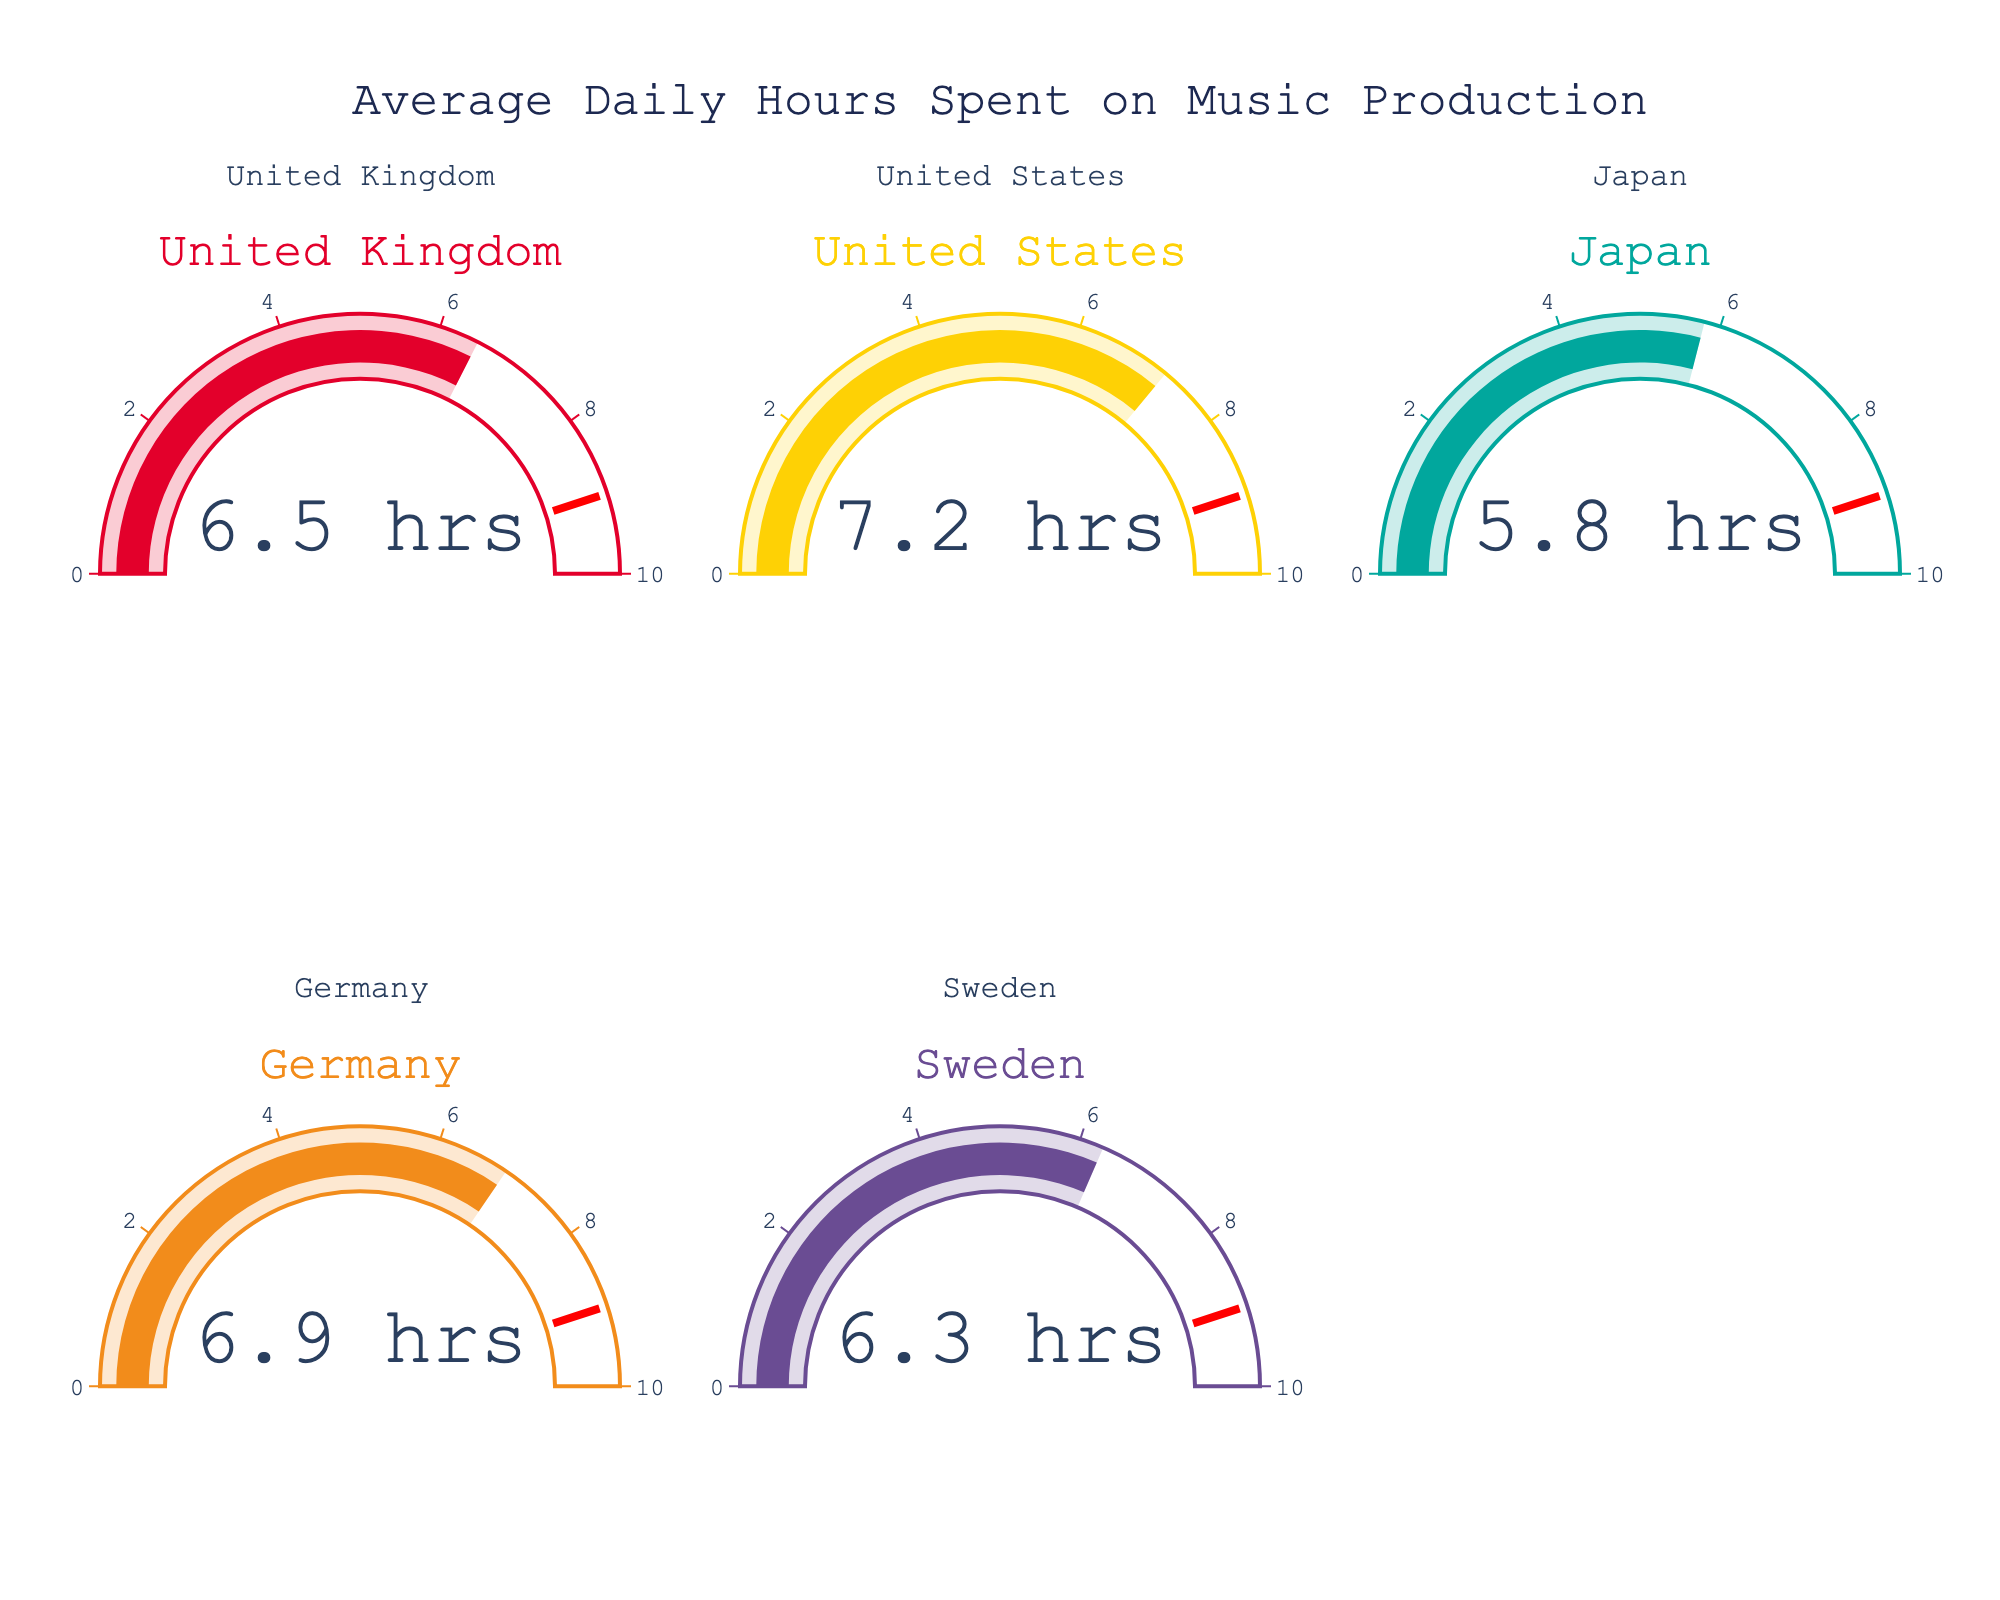What's the title of the figure? The title is displayed at the top of the figure. It reads "Average Daily Hours Spent on Music Production".
Answer: Average Daily Hours Spent on Music Production Which country has the highest average daily hours spent on music production? By looking at the gauge charts, the highest value on any gauge is 7.2, which corresponds to the United States.
Answer: United States What is the difference in average daily hours between Germany and the United States? The gauge for Germany shows 6.9 and the gauge for the United States shows 7.2. Subtracting 6.9 from 7.2 gives the difference.
Answer: 0.3 What is the color associated with Japan's gauge chart? Each gauge chart has a specific color. The gauge corresponding to Japan is teal.
Answer: teal What are the average daily hours spent on music production in Sweden and the United Kingdom combined? The gauge for Sweden is 6.3 and for the United Kingdom it is 6.5. Adding these values together gives the sum.
Answer: 12.8 Which country spends less time on music production on average, Japan or Sweden? Comparing the values on the gauges, Japan has 5.8 and Sweden has 6.3. Japan's value is less.
Answer: Japan What's the median value of all the countries' average daily hours spent on music production? To find the median, sort the values: 5.8 (Japan), 6.3 (Sweden), 6.5 (United Kingdom), 6.9 (Germany), and 7.2 (United States). The median is the middle value.
Answer: 6.5 Are any of the average daily hours equal to 6? Looking at all the gauges, none of them show the value as exactly 6.
Answer: No What is the range of the average daily hours spent on music production across these countries? The highest value is 7.2 (United States) and the lowest is 5.8 (Japan). Subtracting the lowest from the highest gives the range.
Answer: 1.4 